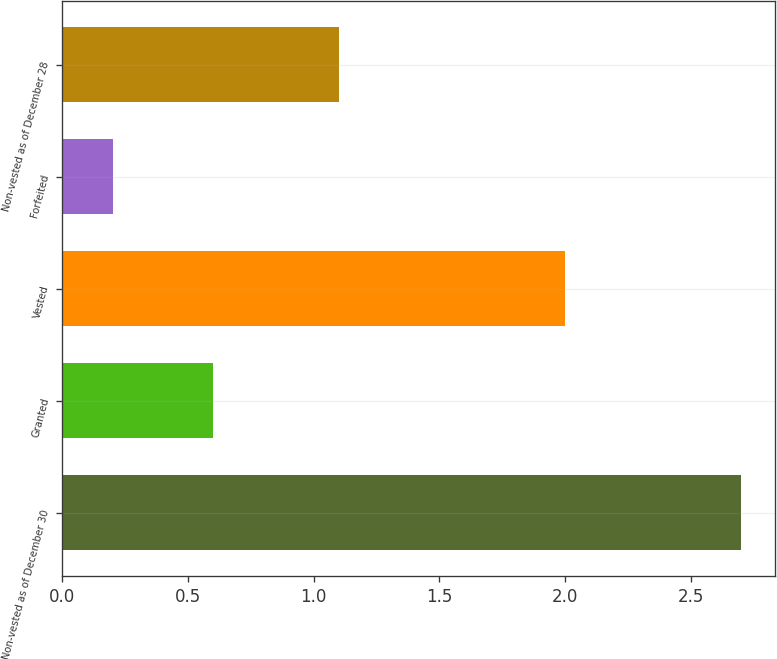Convert chart to OTSL. <chart><loc_0><loc_0><loc_500><loc_500><bar_chart><fcel>Non-vested as of December 30<fcel>Granted<fcel>Vested<fcel>Forfeited<fcel>Non-vested as of December 28<nl><fcel>2.7<fcel>0.6<fcel>2<fcel>0.2<fcel>1.1<nl></chart> 